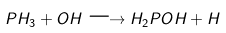<formula> <loc_0><loc_0><loc_500><loc_500>P H _ { 3 } + O H \longrightarrow H _ { 2 } P O H + H</formula> 